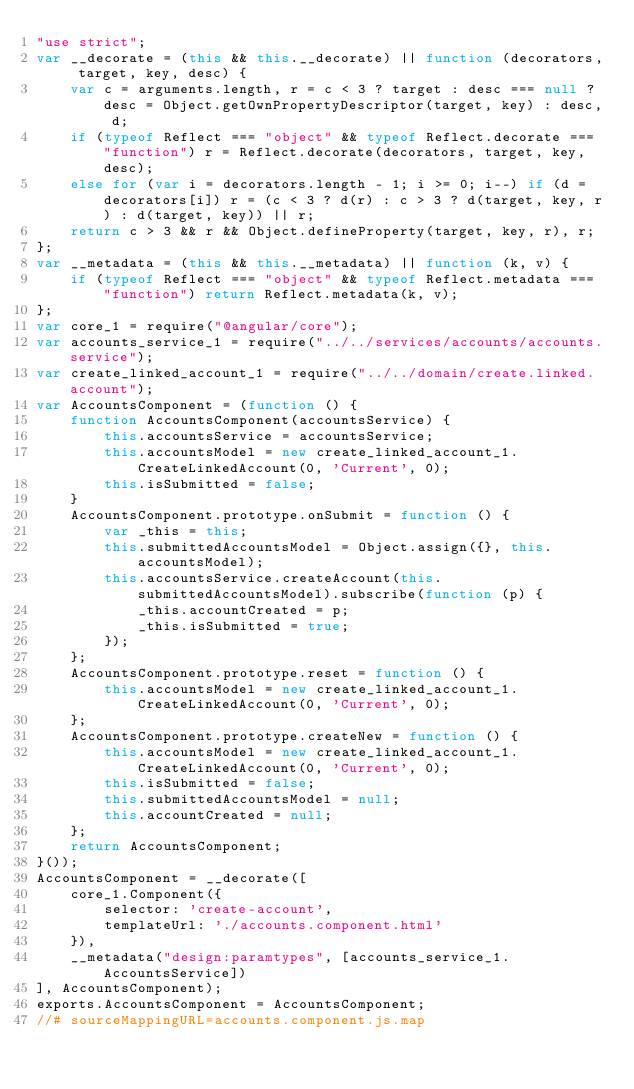<code> <loc_0><loc_0><loc_500><loc_500><_JavaScript_>"use strict";
var __decorate = (this && this.__decorate) || function (decorators, target, key, desc) {
    var c = arguments.length, r = c < 3 ? target : desc === null ? desc = Object.getOwnPropertyDescriptor(target, key) : desc, d;
    if (typeof Reflect === "object" && typeof Reflect.decorate === "function") r = Reflect.decorate(decorators, target, key, desc);
    else for (var i = decorators.length - 1; i >= 0; i--) if (d = decorators[i]) r = (c < 3 ? d(r) : c > 3 ? d(target, key, r) : d(target, key)) || r;
    return c > 3 && r && Object.defineProperty(target, key, r), r;
};
var __metadata = (this && this.__metadata) || function (k, v) {
    if (typeof Reflect === "object" && typeof Reflect.metadata === "function") return Reflect.metadata(k, v);
};
var core_1 = require("@angular/core");
var accounts_service_1 = require("../../services/accounts/accounts.service");
var create_linked_account_1 = require("../../domain/create.linked.account");
var AccountsComponent = (function () {
    function AccountsComponent(accountsService) {
        this.accountsService = accountsService;
        this.accountsModel = new create_linked_account_1.CreateLinkedAccount(0, 'Current', 0);
        this.isSubmitted = false;
    }
    AccountsComponent.prototype.onSubmit = function () {
        var _this = this;
        this.submittedAccountsModel = Object.assign({}, this.accountsModel);
        this.accountsService.createAccount(this.submittedAccountsModel).subscribe(function (p) {
            _this.accountCreated = p;
            _this.isSubmitted = true;
        });
    };
    AccountsComponent.prototype.reset = function () {
        this.accountsModel = new create_linked_account_1.CreateLinkedAccount(0, 'Current', 0);
    };
    AccountsComponent.prototype.createNew = function () {
        this.accountsModel = new create_linked_account_1.CreateLinkedAccount(0, 'Current', 0);
        this.isSubmitted = false;
        this.submittedAccountsModel = null;
        this.accountCreated = null;
    };
    return AccountsComponent;
}());
AccountsComponent = __decorate([
    core_1.Component({
        selector: 'create-account',
        templateUrl: './accounts.component.html'
    }),
    __metadata("design:paramtypes", [accounts_service_1.AccountsService])
], AccountsComponent);
exports.AccountsComponent = AccountsComponent;
//# sourceMappingURL=accounts.component.js.map</code> 